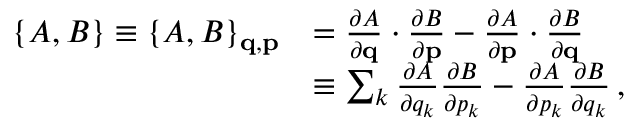Convert formula to latex. <formula><loc_0><loc_0><loc_500><loc_500>{ \begin{array} { r l } { \{ A , B \} \equiv \{ A , B \} _ { q , p } } & { = { \frac { \partial A } { \partial q } } \cdot { \frac { \partial B } { \partial p } } - { \frac { \partial A } { \partial p } } \cdot { \frac { \partial B } { \partial q } } } \\ & { \equiv \sum _ { k } { \frac { \partial A } { \partial q _ { k } } } { \frac { \partial B } { \partial p _ { k } } } - { \frac { \partial A } { \partial p _ { k } } } { \frac { \partial B } { \partial q _ { k } } } \, , } \end{array} }</formula> 